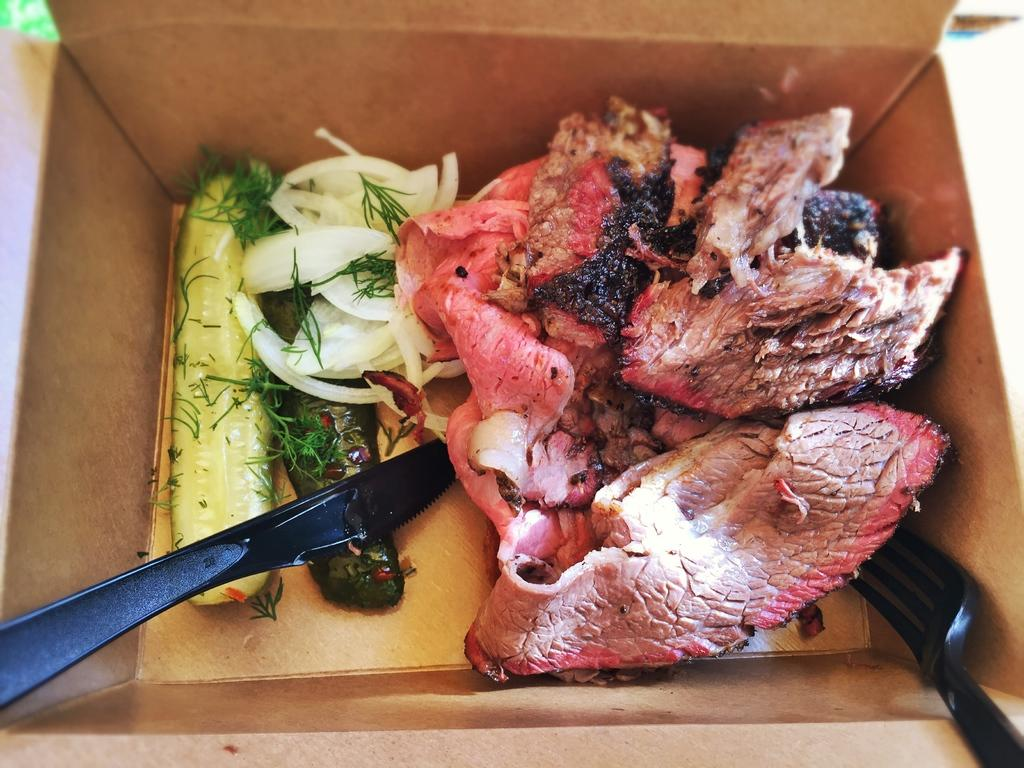What is in the box that is visible in the image? The box contains vegetables and meat. What utensils are present in the box? There is a knife and a fork in the box. What type of plant can be seen growing inside the box? There is no plant visible inside the box; it contains vegetables and meat. 